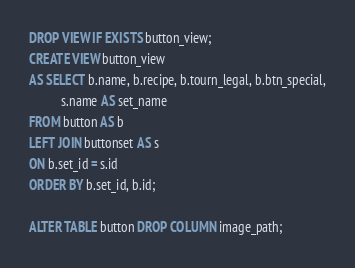Convert code to text. <code><loc_0><loc_0><loc_500><loc_500><_SQL_>DROP VIEW IF EXISTS button_view;
CREATE VIEW button_view
AS SELECT b.name, b.recipe, b.tourn_legal, b.btn_special,
          s.name AS set_name
FROM button AS b
LEFT JOIN buttonset AS s
ON b.set_id = s.id
ORDER BY b.set_id, b.id;

ALTER TABLE button DROP COLUMN image_path;
</code> 